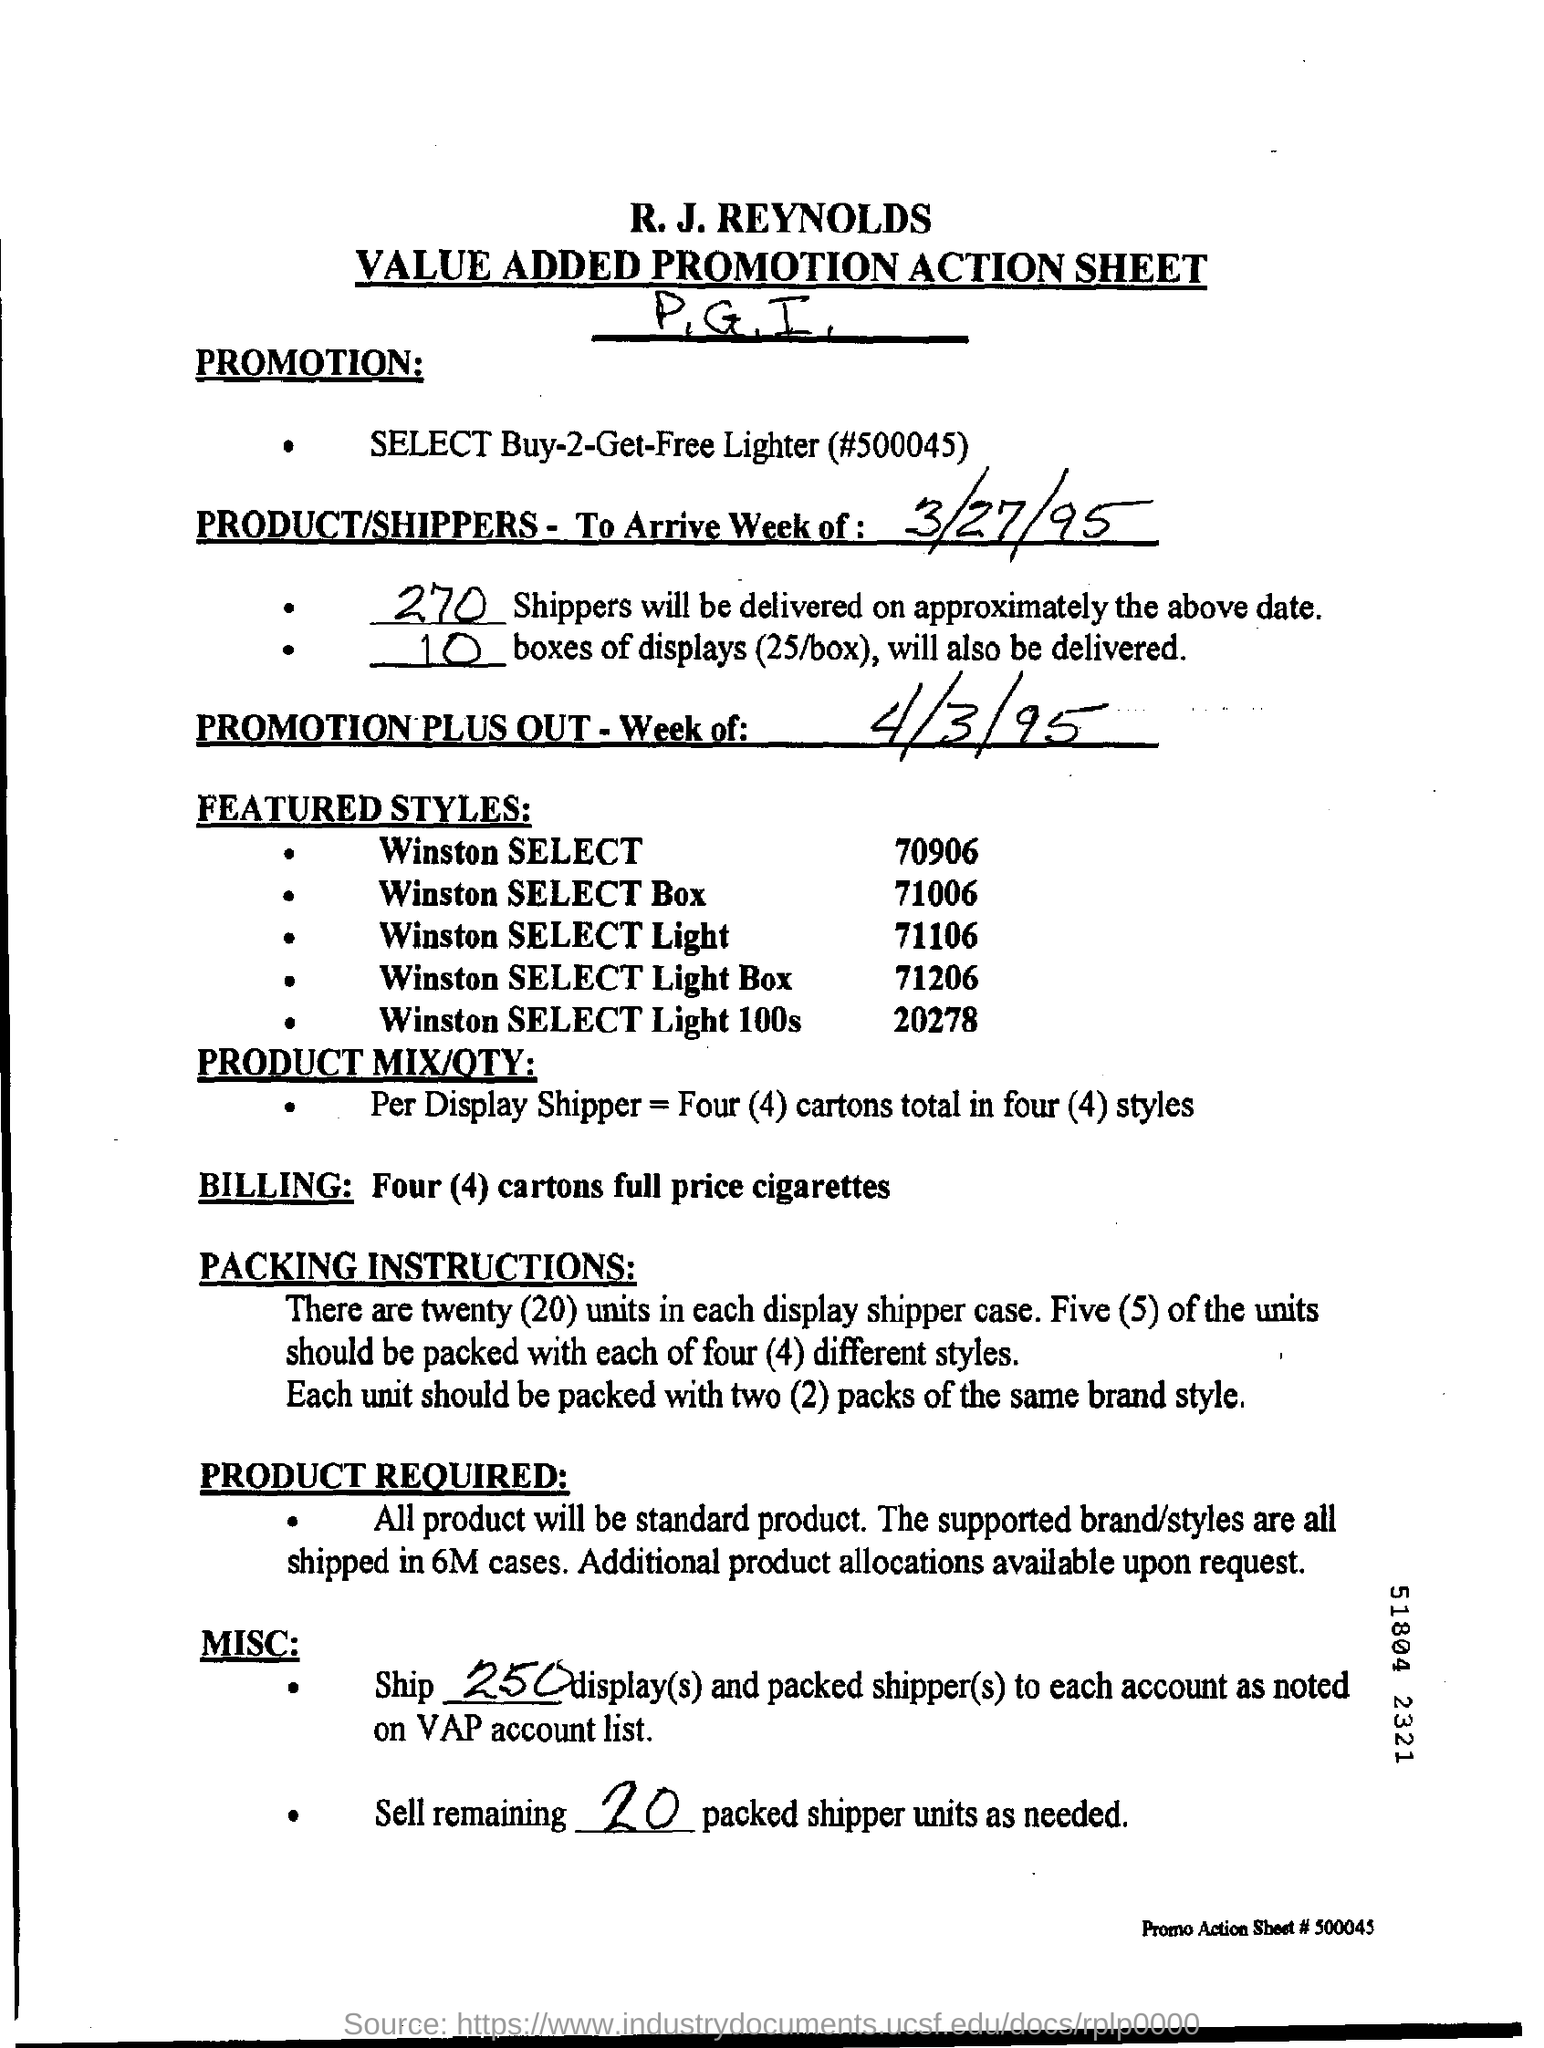What is the first title in the document?
Ensure brevity in your answer.  R.J.Reynolds. What is the second title in this document?
Make the answer very short. Value Added Promotion Action Sheet. 